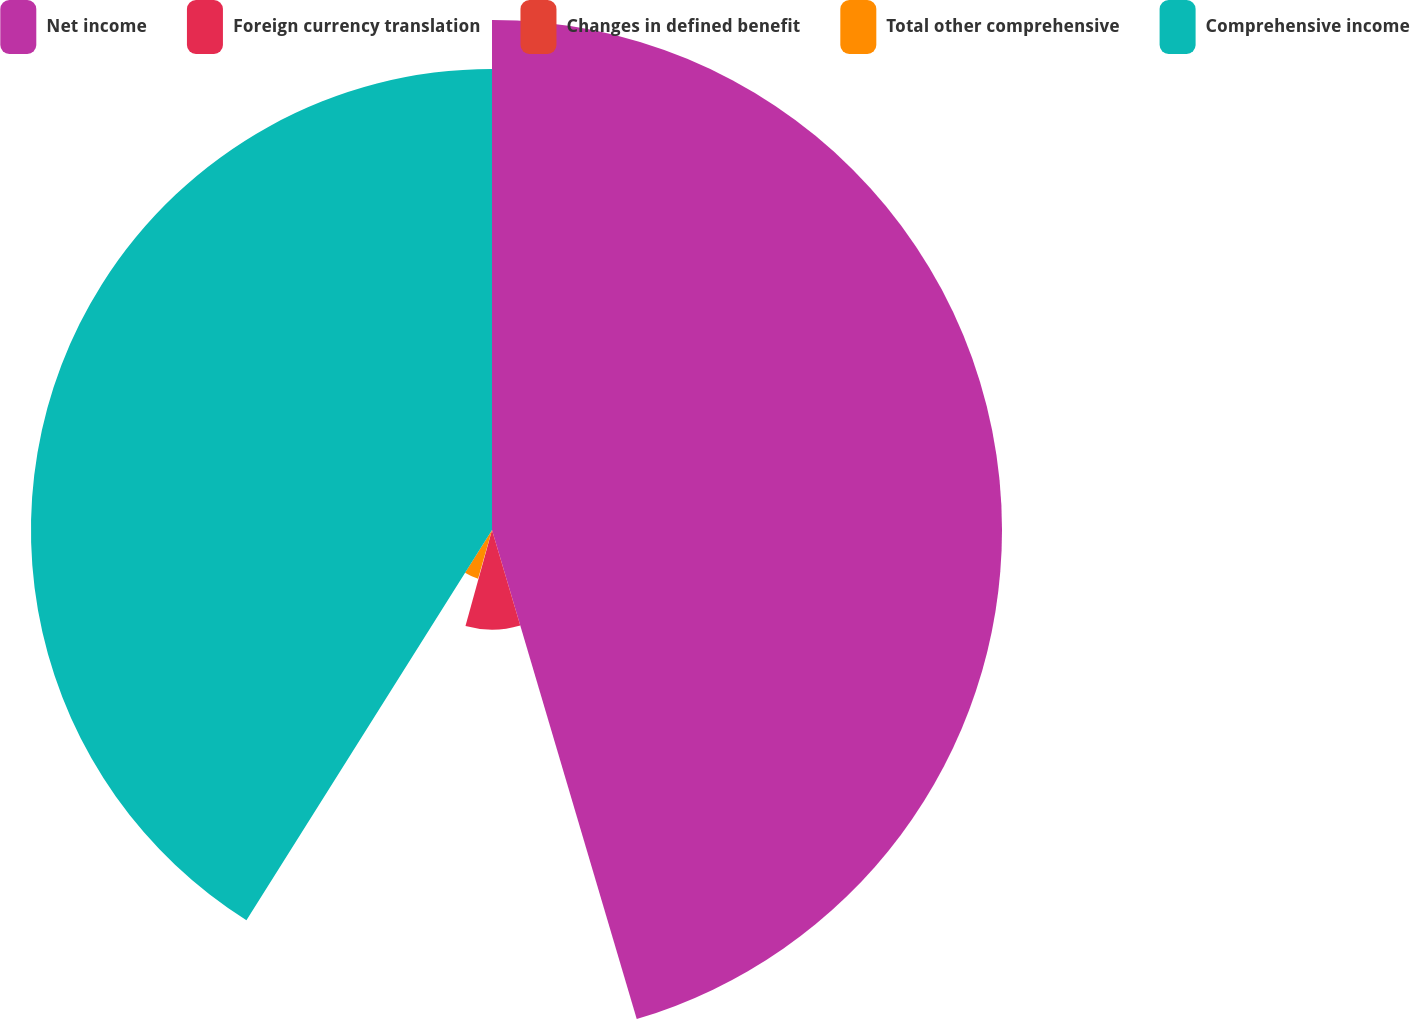Convert chart to OTSL. <chart><loc_0><loc_0><loc_500><loc_500><pie_chart><fcel>Net income<fcel>Foreign currency translation<fcel>Changes in defined benefit<fcel>Total other comprehensive<fcel>Comprehensive income<nl><fcel>45.42%<fcel>8.87%<fcel>0.14%<fcel>4.51%<fcel>41.06%<nl></chart> 